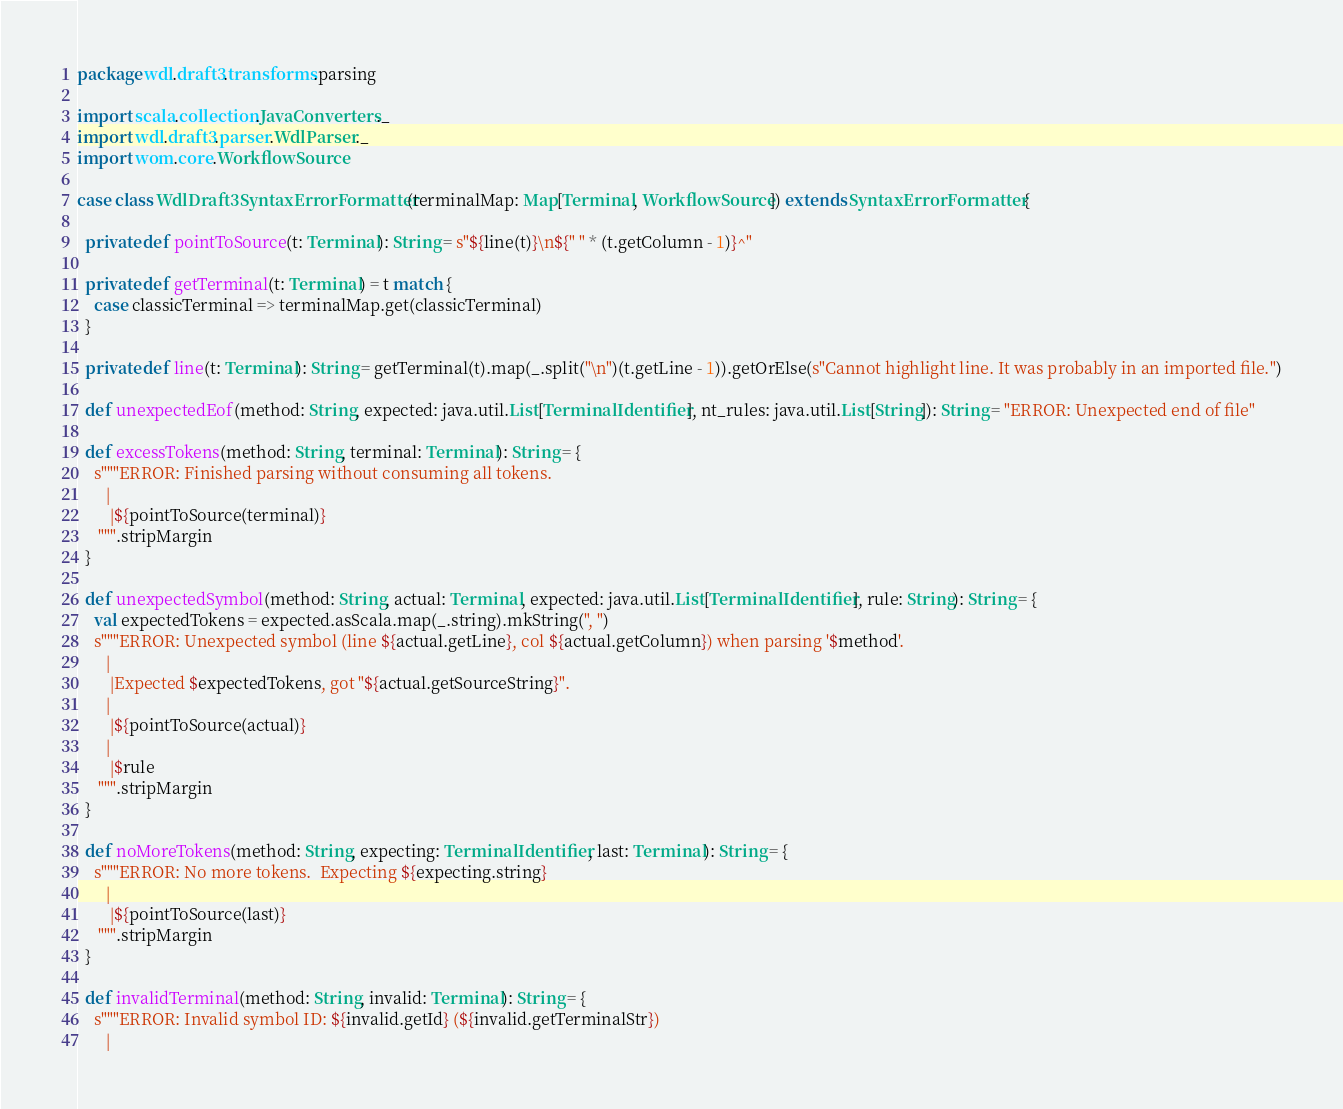Convert code to text. <code><loc_0><loc_0><loc_500><loc_500><_Scala_>package wdl.draft3.transforms.parsing

import scala.collection.JavaConverters._
import wdl.draft3.parser.WdlParser._
import wom.core.WorkflowSource

case class WdlDraft3SyntaxErrorFormatter(terminalMap: Map[Terminal, WorkflowSource]) extends SyntaxErrorFormatter {

  private def pointToSource(t: Terminal): String = s"${line(t)}\n${" " * (t.getColumn - 1)}^"

  private def getTerminal(t: Terminal) = t match {
    case classicTerminal => terminalMap.get(classicTerminal)
  }

  private def line(t: Terminal): String = getTerminal(t).map(_.split("\n")(t.getLine - 1)).getOrElse(s"Cannot highlight line. It was probably in an imported file.")

  def unexpectedEof(method: String, expected: java.util.List[TerminalIdentifier], nt_rules: java.util.List[String]): String = "ERROR: Unexpected end of file"

  def excessTokens(method: String, terminal: Terminal): String = {
    s"""ERROR: Finished parsing without consuming all tokens.
       |
        |${pointToSource(terminal)}
     """.stripMargin
  }

  def unexpectedSymbol(method: String, actual: Terminal, expected: java.util.List[TerminalIdentifier], rule: String): String = {
    val expectedTokens = expected.asScala.map(_.string).mkString(", ")
    s"""ERROR: Unexpected symbol (line ${actual.getLine}, col ${actual.getColumn}) when parsing '$method'.
       |
        |Expected $expectedTokens, got "${actual.getSourceString}".
       |
        |${pointToSource(actual)}
       |
        |$rule
     """.stripMargin
  }

  def noMoreTokens(method: String, expecting: TerminalIdentifier, last: Terminal): String = {
    s"""ERROR: No more tokens.  Expecting ${expecting.string}
       |
        |${pointToSource(last)}
     """.stripMargin
  }

  def invalidTerminal(method: String, invalid: Terminal): String = {
    s"""ERROR: Invalid symbol ID: ${invalid.getId} (${invalid.getTerminalStr})
       |</code> 